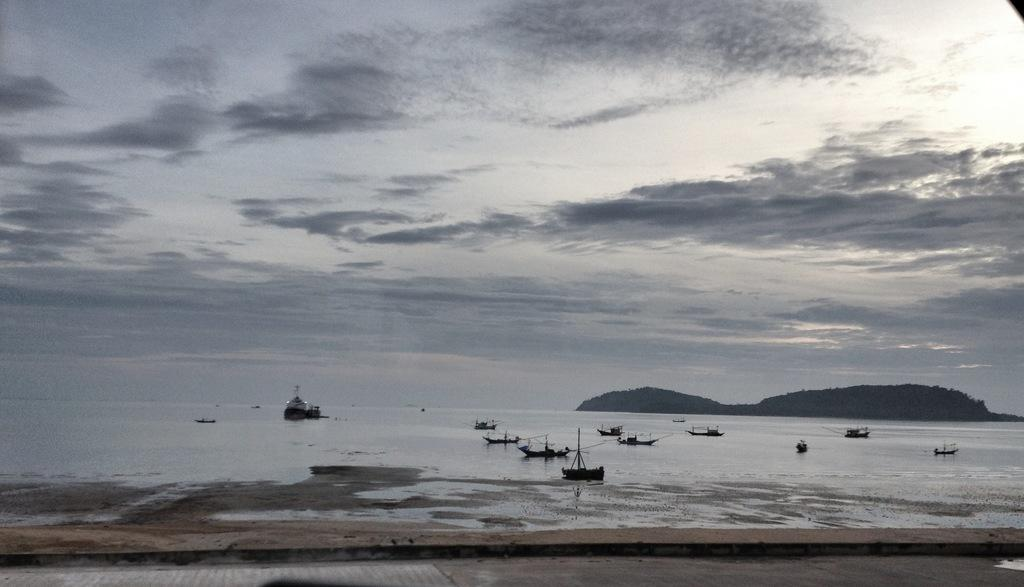What can be seen in the foreground of the image? There is a path in the foreground of the image. What can be seen in the background of the image? There are boats, a ship, mountains, and the sky visible in the background of the image. What is the condition of the sky in the image? The sky is visible in the background of the image, and there are clouds present. What type of juice is being served on the ship in the image? There is no juice present in the image; it features a path in the foreground and boats, a ship, mountains, and the sky in the background. What is the temper of the person operating the ship in the image? There is no indication of the person's temper in the image, as it only shows the ship and other elements in the background. 